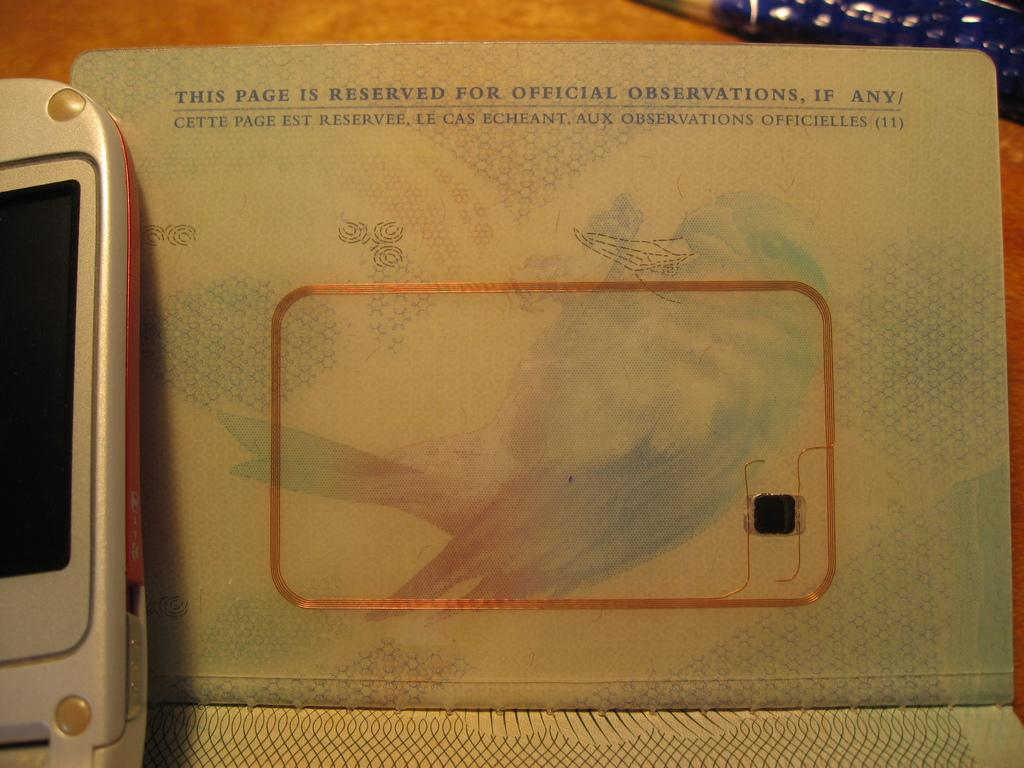<image>
Provide a brief description of the given image. a page is reserved for official observations if any 